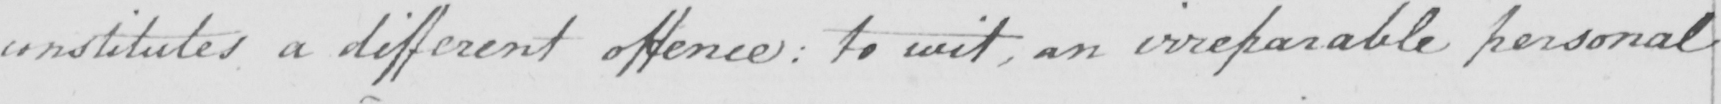Transcribe the text shown in this historical manuscript line. institutes a different offence :  to wit , an irreparable personal 